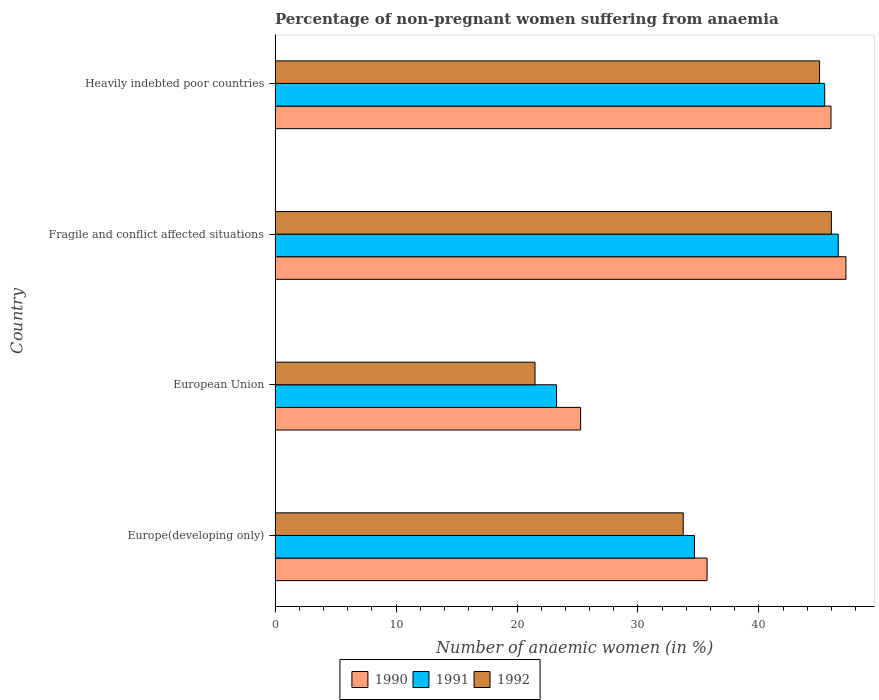How many bars are there on the 3rd tick from the bottom?
Provide a succinct answer. 3. What is the label of the 1st group of bars from the top?
Offer a terse response. Heavily indebted poor countries. In how many cases, is the number of bars for a given country not equal to the number of legend labels?
Your response must be concise. 0. What is the percentage of non-pregnant women suffering from anaemia in 1991 in Fragile and conflict affected situations?
Ensure brevity in your answer.  46.56. Across all countries, what is the maximum percentage of non-pregnant women suffering from anaemia in 1991?
Make the answer very short. 46.56. Across all countries, what is the minimum percentage of non-pregnant women suffering from anaemia in 1991?
Ensure brevity in your answer.  23.27. In which country was the percentage of non-pregnant women suffering from anaemia in 1991 maximum?
Your response must be concise. Fragile and conflict affected situations. In which country was the percentage of non-pregnant women suffering from anaemia in 1992 minimum?
Your response must be concise. European Union. What is the total percentage of non-pregnant women suffering from anaemia in 1991 in the graph?
Ensure brevity in your answer.  149.93. What is the difference between the percentage of non-pregnant women suffering from anaemia in 1990 in European Union and that in Fragile and conflict affected situations?
Keep it short and to the point. -21.94. What is the difference between the percentage of non-pregnant women suffering from anaemia in 1991 in European Union and the percentage of non-pregnant women suffering from anaemia in 1992 in Europe(developing only)?
Offer a terse response. -10.48. What is the average percentage of non-pregnant women suffering from anaemia in 1990 per country?
Your answer should be very brief. 38.53. What is the difference between the percentage of non-pregnant women suffering from anaemia in 1992 and percentage of non-pregnant women suffering from anaemia in 1990 in Fragile and conflict affected situations?
Offer a terse response. -1.2. In how many countries, is the percentage of non-pregnant women suffering from anaemia in 1990 greater than 40 %?
Provide a succinct answer. 2. What is the ratio of the percentage of non-pregnant women suffering from anaemia in 1991 in Europe(developing only) to that in Heavily indebted poor countries?
Provide a succinct answer. 0.76. Is the percentage of non-pregnant women suffering from anaemia in 1990 in Europe(developing only) less than that in Heavily indebted poor countries?
Provide a succinct answer. Yes. What is the difference between the highest and the second highest percentage of non-pregnant women suffering from anaemia in 1992?
Offer a terse response. 0.98. What is the difference between the highest and the lowest percentage of non-pregnant women suffering from anaemia in 1991?
Provide a succinct answer. 23.29. Is it the case that in every country, the sum of the percentage of non-pregnant women suffering from anaemia in 1992 and percentage of non-pregnant women suffering from anaemia in 1991 is greater than the percentage of non-pregnant women suffering from anaemia in 1990?
Keep it short and to the point. Yes. How many countries are there in the graph?
Ensure brevity in your answer.  4. What is the difference between two consecutive major ticks on the X-axis?
Keep it short and to the point. 10. Does the graph contain grids?
Keep it short and to the point. No. Where does the legend appear in the graph?
Ensure brevity in your answer.  Bottom center. What is the title of the graph?
Give a very brief answer. Percentage of non-pregnant women suffering from anaemia. Does "1989" appear as one of the legend labels in the graph?
Provide a short and direct response. No. What is the label or title of the X-axis?
Provide a short and direct response. Number of anaemic women (in %). What is the label or title of the Y-axis?
Ensure brevity in your answer.  Country. What is the Number of anaemic women (in %) in 1990 in Europe(developing only)?
Give a very brief answer. 35.71. What is the Number of anaemic women (in %) of 1991 in Europe(developing only)?
Offer a very short reply. 34.67. What is the Number of anaemic women (in %) in 1992 in Europe(developing only)?
Ensure brevity in your answer.  33.74. What is the Number of anaemic women (in %) in 1990 in European Union?
Your answer should be very brief. 25.26. What is the Number of anaemic women (in %) of 1991 in European Union?
Give a very brief answer. 23.27. What is the Number of anaemic women (in %) in 1992 in European Union?
Offer a very short reply. 21.49. What is the Number of anaemic women (in %) in 1990 in Fragile and conflict affected situations?
Ensure brevity in your answer.  47.19. What is the Number of anaemic women (in %) of 1991 in Fragile and conflict affected situations?
Provide a short and direct response. 46.56. What is the Number of anaemic women (in %) of 1992 in Fragile and conflict affected situations?
Keep it short and to the point. 45.99. What is the Number of anaemic women (in %) in 1990 in Heavily indebted poor countries?
Ensure brevity in your answer.  45.96. What is the Number of anaemic women (in %) of 1991 in Heavily indebted poor countries?
Make the answer very short. 45.44. What is the Number of anaemic women (in %) in 1992 in Heavily indebted poor countries?
Provide a short and direct response. 45.01. Across all countries, what is the maximum Number of anaemic women (in %) in 1990?
Provide a succinct answer. 47.19. Across all countries, what is the maximum Number of anaemic women (in %) of 1991?
Ensure brevity in your answer.  46.56. Across all countries, what is the maximum Number of anaemic women (in %) of 1992?
Your response must be concise. 45.99. Across all countries, what is the minimum Number of anaemic women (in %) in 1990?
Offer a terse response. 25.26. Across all countries, what is the minimum Number of anaemic women (in %) in 1991?
Your answer should be very brief. 23.27. Across all countries, what is the minimum Number of anaemic women (in %) of 1992?
Ensure brevity in your answer.  21.49. What is the total Number of anaemic women (in %) in 1990 in the graph?
Keep it short and to the point. 154.12. What is the total Number of anaemic women (in %) in 1991 in the graph?
Ensure brevity in your answer.  149.93. What is the total Number of anaemic women (in %) of 1992 in the graph?
Give a very brief answer. 146.24. What is the difference between the Number of anaemic women (in %) in 1990 in Europe(developing only) and that in European Union?
Your answer should be very brief. 10.45. What is the difference between the Number of anaemic women (in %) of 1991 in Europe(developing only) and that in European Union?
Offer a very short reply. 11.4. What is the difference between the Number of anaemic women (in %) of 1992 in Europe(developing only) and that in European Union?
Make the answer very short. 12.25. What is the difference between the Number of anaemic women (in %) of 1990 in Europe(developing only) and that in Fragile and conflict affected situations?
Offer a terse response. -11.48. What is the difference between the Number of anaemic women (in %) in 1991 in Europe(developing only) and that in Fragile and conflict affected situations?
Keep it short and to the point. -11.89. What is the difference between the Number of anaemic women (in %) in 1992 in Europe(developing only) and that in Fragile and conflict affected situations?
Make the answer very short. -12.25. What is the difference between the Number of anaemic women (in %) of 1990 in Europe(developing only) and that in Heavily indebted poor countries?
Ensure brevity in your answer.  -10.24. What is the difference between the Number of anaemic women (in %) in 1991 in Europe(developing only) and that in Heavily indebted poor countries?
Give a very brief answer. -10.76. What is the difference between the Number of anaemic women (in %) in 1992 in Europe(developing only) and that in Heavily indebted poor countries?
Ensure brevity in your answer.  -11.27. What is the difference between the Number of anaemic women (in %) in 1990 in European Union and that in Fragile and conflict affected situations?
Offer a very short reply. -21.94. What is the difference between the Number of anaemic women (in %) in 1991 in European Union and that in Fragile and conflict affected situations?
Ensure brevity in your answer.  -23.29. What is the difference between the Number of anaemic women (in %) in 1992 in European Union and that in Fragile and conflict affected situations?
Your answer should be very brief. -24.5. What is the difference between the Number of anaemic women (in %) of 1990 in European Union and that in Heavily indebted poor countries?
Make the answer very short. -20.7. What is the difference between the Number of anaemic women (in %) of 1991 in European Union and that in Heavily indebted poor countries?
Provide a succinct answer. -22.17. What is the difference between the Number of anaemic women (in %) in 1992 in European Union and that in Heavily indebted poor countries?
Your response must be concise. -23.52. What is the difference between the Number of anaemic women (in %) of 1990 in Fragile and conflict affected situations and that in Heavily indebted poor countries?
Make the answer very short. 1.24. What is the difference between the Number of anaemic women (in %) in 1991 in Fragile and conflict affected situations and that in Heavily indebted poor countries?
Offer a very short reply. 1.12. What is the difference between the Number of anaemic women (in %) of 1990 in Europe(developing only) and the Number of anaemic women (in %) of 1991 in European Union?
Your response must be concise. 12.45. What is the difference between the Number of anaemic women (in %) of 1990 in Europe(developing only) and the Number of anaemic women (in %) of 1992 in European Union?
Keep it short and to the point. 14.22. What is the difference between the Number of anaemic women (in %) in 1991 in Europe(developing only) and the Number of anaemic women (in %) in 1992 in European Union?
Your response must be concise. 13.18. What is the difference between the Number of anaemic women (in %) in 1990 in Europe(developing only) and the Number of anaemic women (in %) in 1991 in Fragile and conflict affected situations?
Your answer should be compact. -10.84. What is the difference between the Number of anaemic women (in %) in 1990 in Europe(developing only) and the Number of anaemic women (in %) in 1992 in Fragile and conflict affected situations?
Your answer should be very brief. -10.28. What is the difference between the Number of anaemic women (in %) of 1991 in Europe(developing only) and the Number of anaemic women (in %) of 1992 in Fragile and conflict affected situations?
Your answer should be very brief. -11.32. What is the difference between the Number of anaemic women (in %) of 1990 in Europe(developing only) and the Number of anaemic women (in %) of 1991 in Heavily indebted poor countries?
Keep it short and to the point. -9.72. What is the difference between the Number of anaemic women (in %) of 1990 in Europe(developing only) and the Number of anaemic women (in %) of 1992 in Heavily indebted poor countries?
Provide a short and direct response. -9.3. What is the difference between the Number of anaemic women (in %) in 1991 in Europe(developing only) and the Number of anaemic women (in %) in 1992 in Heavily indebted poor countries?
Your answer should be compact. -10.34. What is the difference between the Number of anaemic women (in %) of 1990 in European Union and the Number of anaemic women (in %) of 1991 in Fragile and conflict affected situations?
Offer a very short reply. -21.3. What is the difference between the Number of anaemic women (in %) of 1990 in European Union and the Number of anaemic women (in %) of 1992 in Fragile and conflict affected situations?
Make the answer very short. -20.73. What is the difference between the Number of anaemic women (in %) of 1991 in European Union and the Number of anaemic women (in %) of 1992 in Fragile and conflict affected situations?
Give a very brief answer. -22.72. What is the difference between the Number of anaemic women (in %) in 1990 in European Union and the Number of anaemic women (in %) in 1991 in Heavily indebted poor countries?
Your answer should be compact. -20.18. What is the difference between the Number of anaemic women (in %) of 1990 in European Union and the Number of anaemic women (in %) of 1992 in Heavily indebted poor countries?
Offer a very short reply. -19.76. What is the difference between the Number of anaemic women (in %) of 1991 in European Union and the Number of anaemic women (in %) of 1992 in Heavily indebted poor countries?
Provide a succinct answer. -21.75. What is the difference between the Number of anaemic women (in %) of 1990 in Fragile and conflict affected situations and the Number of anaemic women (in %) of 1991 in Heavily indebted poor countries?
Give a very brief answer. 1.76. What is the difference between the Number of anaemic women (in %) in 1990 in Fragile and conflict affected situations and the Number of anaemic women (in %) in 1992 in Heavily indebted poor countries?
Your answer should be very brief. 2.18. What is the difference between the Number of anaemic women (in %) of 1991 in Fragile and conflict affected situations and the Number of anaemic women (in %) of 1992 in Heavily indebted poor countries?
Your response must be concise. 1.54. What is the average Number of anaemic women (in %) in 1990 per country?
Make the answer very short. 38.53. What is the average Number of anaemic women (in %) of 1991 per country?
Your response must be concise. 37.48. What is the average Number of anaemic women (in %) of 1992 per country?
Your answer should be very brief. 36.56. What is the difference between the Number of anaemic women (in %) of 1990 and Number of anaemic women (in %) of 1991 in Europe(developing only)?
Give a very brief answer. 1.04. What is the difference between the Number of anaemic women (in %) in 1990 and Number of anaemic women (in %) in 1992 in Europe(developing only)?
Make the answer very short. 1.97. What is the difference between the Number of anaemic women (in %) in 1991 and Number of anaemic women (in %) in 1992 in Europe(developing only)?
Make the answer very short. 0.93. What is the difference between the Number of anaemic women (in %) of 1990 and Number of anaemic women (in %) of 1991 in European Union?
Your response must be concise. 1.99. What is the difference between the Number of anaemic women (in %) of 1990 and Number of anaemic women (in %) of 1992 in European Union?
Your answer should be compact. 3.77. What is the difference between the Number of anaemic women (in %) of 1991 and Number of anaemic women (in %) of 1992 in European Union?
Your answer should be compact. 1.78. What is the difference between the Number of anaemic women (in %) of 1990 and Number of anaemic women (in %) of 1991 in Fragile and conflict affected situations?
Your answer should be compact. 0.64. What is the difference between the Number of anaemic women (in %) in 1990 and Number of anaemic women (in %) in 1992 in Fragile and conflict affected situations?
Provide a short and direct response. 1.2. What is the difference between the Number of anaemic women (in %) in 1991 and Number of anaemic women (in %) in 1992 in Fragile and conflict affected situations?
Provide a succinct answer. 0.56. What is the difference between the Number of anaemic women (in %) in 1990 and Number of anaemic women (in %) in 1991 in Heavily indebted poor countries?
Your answer should be compact. 0.52. What is the difference between the Number of anaemic women (in %) of 1990 and Number of anaemic women (in %) of 1992 in Heavily indebted poor countries?
Ensure brevity in your answer.  0.94. What is the difference between the Number of anaemic women (in %) in 1991 and Number of anaemic women (in %) in 1992 in Heavily indebted poor countries?
Provide a succinct answer. 0.42. What is the ratio of the Number of anaemic women (in %) in 1990 in Europe(developing only) to that in European Union?
Your response must be concise. 1.41. What is the ratio of the Number of anaemic women (in %) in 1991 in Europe(developing only) to that in European Union?
Offer a very short reply. 1.49. What is the ratio of the Number of anaemic women (in %) of 1992 in Europe(developing only) to that in European Union?
Keep it short and to the point. 1.57. What is the ratio of the Number of anaemic women (in %) of 1990 in Europe(developing only) to that in Fragile and conflict affected situations?
Your response must be concise. 0.76. What is the ratio of the Number of anaemic women (in %) of 1991 in Europe(developing only) to that in Fragile and conflict affected situations?
Offer a terse response. 0.74. What is the ratio of the Number of anaemic women (in %) of 1992 in Europe(developing only) to that in Fragile and conflict affected situations?
Your response must be concise. 0.73. What is the ratio of the Number of anaemic women (in %) of 1990 in Europe(developing only) to that in Heavily indebted poor countries?
Give a very brief answer. 0.78. What is the ratio of the Number of anaemic women (in %) of 1991 in Europe(developing only) to that in Heavily indebted poor countries?
Provide a short and direct response. 0.76. What is the ratio of the Number of anaemic women (in %) in 1992 in Europe(developing only) to that in Heavily indebted poor countries?
Offer a very short reply. 0.75. What is the ratio of the Number of anaemic women (in %) in 1990 in European Union to that in Fragile and conflict affected situations?
Your answer should be compact. 0.54. What is the ratio of the Number of anaemic women (in %) in 1991 in European Union to that in Fragile and conflict affected situations?
Give a very brief answer. 0.5. What is the ratio of the Number of anaemic women (in %) of 1992 in European Union to that in Fragile and conflict affected situations?
Keep it short and to the point. 0.47. What is the ratio of the Number of anaemic women (in %) of 1990 in European Union to that in Heavily indebted poor countries?
Make the answer very short. 0.55. What is the ratio of the Number of anaemic women (in %) in 1991 in European Union to that in Heavily indebted poor countries?
Ensure brevity in your answer.  0.51. What is the ratio of the Number of anaemic women (in %) of 1992 in European Union to that in Heavily indebted poor countries?
Give a very brief answer. 0.48. What is the ratio of the Number of anaemic women (in %) in 1990 in Fragile and conflict affected situations to that in Heavily indebted poor countries?
Give a very brief answer. 1.03. What is the ratio of the Number of anaemic women (in %) in 1991 in Fragile and conflict affected situations to that in Heavily indebted poor countries?
Ensure brevity in your answer.  1.02. What is the ratio of the Number of anaemic women (in %) in 1992 in Fragile and conflict affected situations to that in Heavily indebted poor countries?
Your answer should be very brief. 1.02. What is the difference between the highest and the second highest Number of anaemic women (in %) of 1990?
Your answer should be very brief. 1.24. What is the difference between the highest and the second highest Number of anaemic women (in %) of 1991?
Your response must be concise. 1.12. What is the difference between the highest and the second highest Number of anaemic women (in %) of 1992?
Provide a short and direct response. 0.98. What is the difference between the highest and the lowest Number of anaemic women (in %) in 1990?
Provide a succinct answer. 21.94. What is the difference between the highest and the lowest Number of anaemic women (in %) of 1991?
Offer a terse response. 23.29. What is the difference between the highest and the lowest Number of anaemic women (in %) of 1992?
Provide a succinct answer. 24.5. 